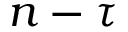<formula> <loc_0><loc_0><loc_500><loc_500>n - \tau</formula> 